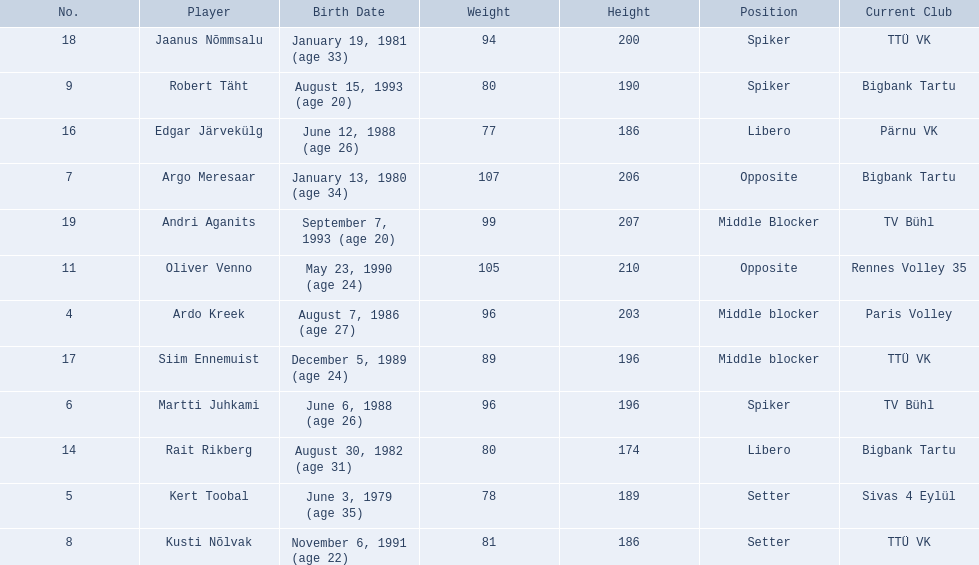What are the heights in cm of the men on the team? 203, 189, 196, 206, 186, 190, 210, 174, 186, 196, 200, 207. What is the tallest height of a team member? 210. Which player stands at 210? Oliver Venno. 